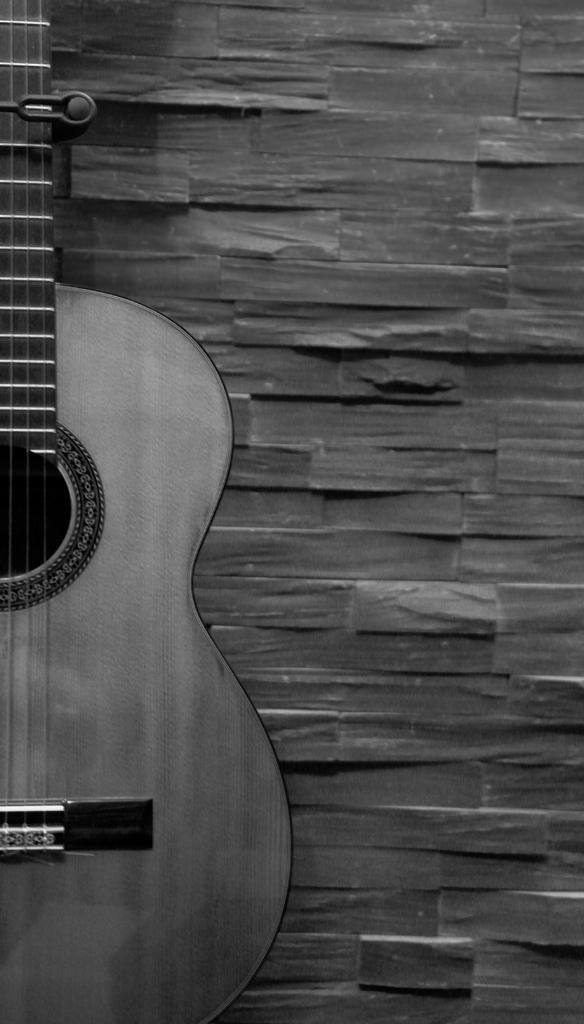What musical instrument is placed towards the wall in the image? There is a guitar placed towards the wall in the image. What can be seen on the wall in the image? There is a wall with a different design in the image. How does the guitar produce steam while playing in the image? The guitar does not produce steam while playing in the image, as guitars do not emit steam. 